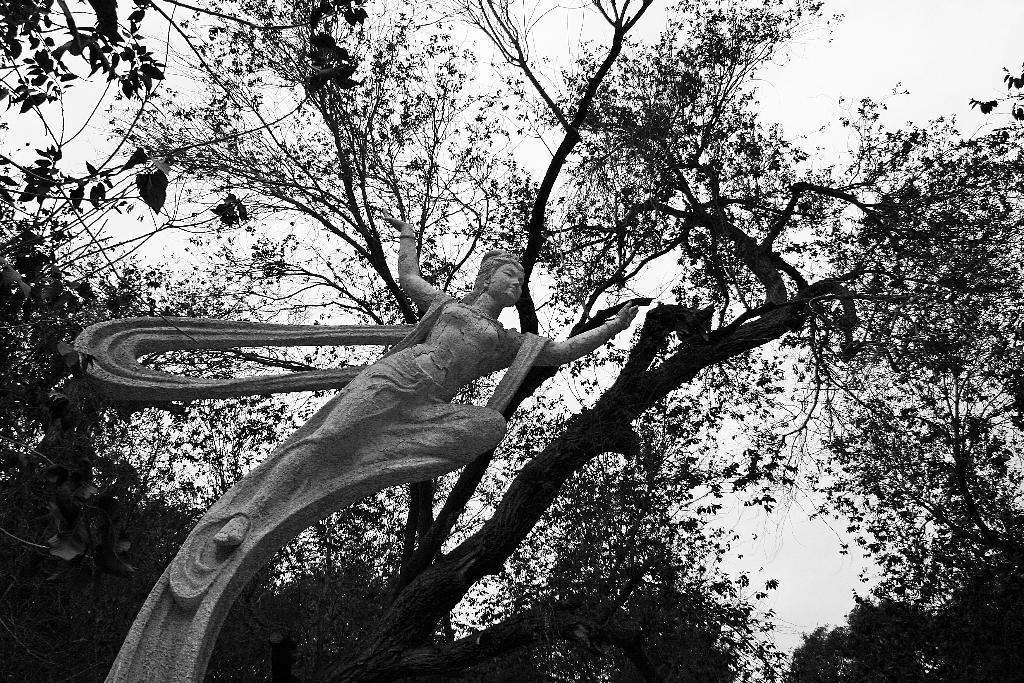What is the main subject in the image? There is a statue in the image. What type of natural elements can be seen in the image? There are trees visible in the image. How would you describe the weather based on the image? The sky is cloudy in the image, suggesting a potentially overcast or cloudy day. What is the name of the person wearing a hat in the image? There is no person wearing a hat in the image, as the main subject is a statue. 